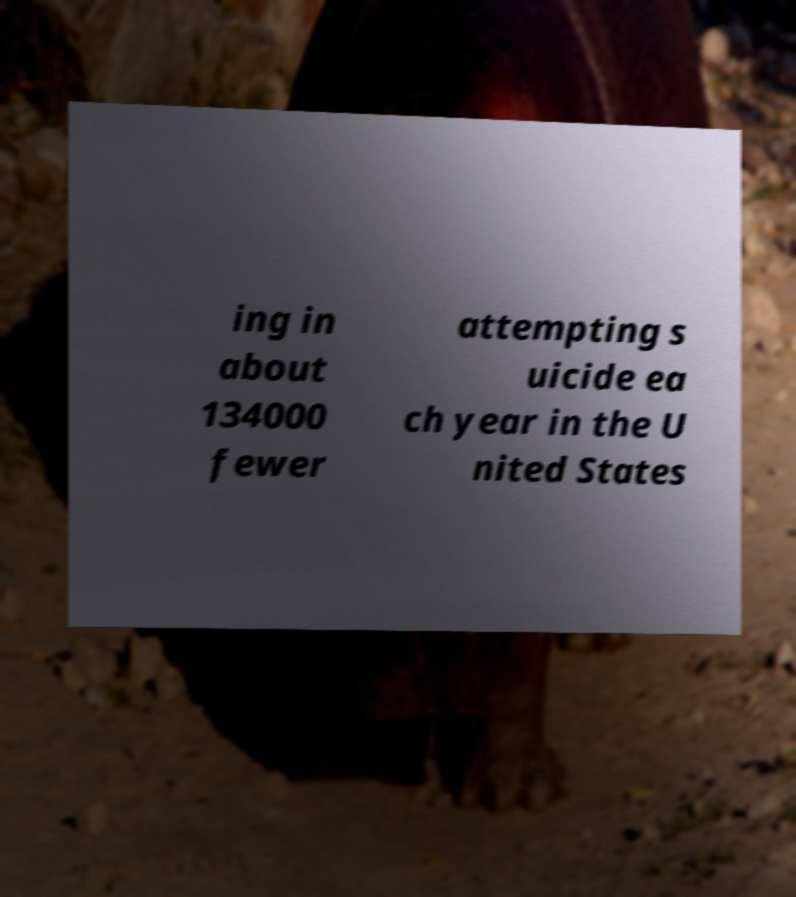Please identify and transcribe the text found in this image. ing in about 134000 fewer attempting s uicide ea ch year in the U nited States 